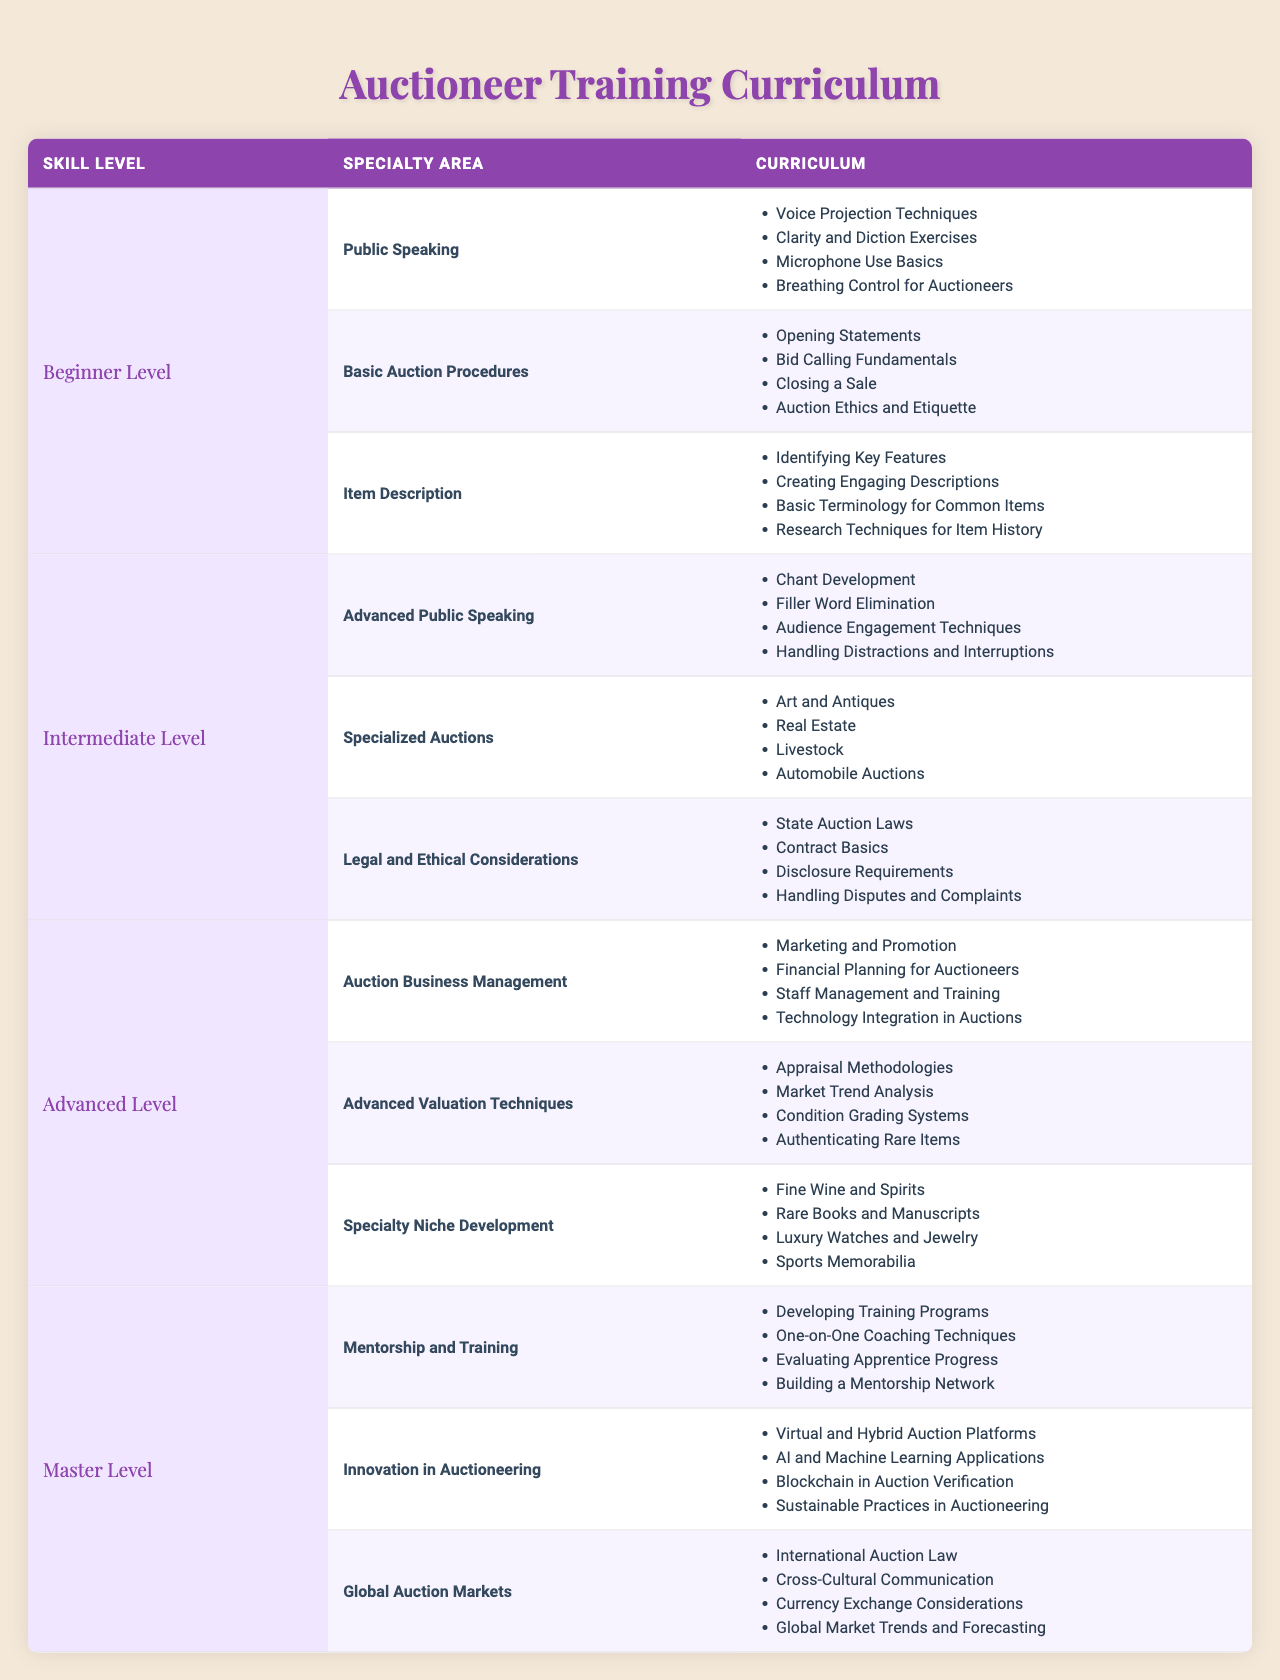What are the curriculum items included in the Basic Auction Procedures at the Beginner Level? The table shows that there are four items under Basic Auction Procedures: Opening Statements, Bid Calling Fundamentals, Closing a Sale, and Auction Ethics and Etiquette. These can be found under the section labeled as Basic Auction Procedures in the Beginner Level category.
Answer: Opening Statements, Bid Calling Fundamentals, Closing a Sale, Auction Ethics and Etiquette Which specialty area at the Intermediate Level covers the auctions for rare items or collectibles? The table lists Specialized Auctions under the Intermediate Level. This area specifically mentions Art and Antiques, which often includes rare items and collectibles, along with Livestock and Automobile Auctions.
Answer: Specialized Auctions How many curriculum items are listed for the Advanced Valuation Techniques specialty area? There are four items listed for Advanced Valuation Techniques: Appraisal Methodologies, Market Trend Analysis, Condition Grading Systems, and Authenticating Rare Items. By counting the items directly from the table, we find that the total is four.
Answer: 4 Does the Advanced Level include any training related to Auction Business Management? Yes, the table confirms that Auction Business Management is included in the Advanced Level curriculum. It is one of the three specialty areas listed under this level.
Answer: Yes Which level has curriculum related to 'Virtual and Hybrid Auction Platforms'? This item is listed under the Innovation in Auctioneering specialty area at the Master Level. Upon examining the table, it is associated with advanced and innovative concepts in auctioneering.
Answer: Master Level What is the relationship between the number of specialty areas and curriculum items in the Beginner Level? The Beginner Level has three specialty areas: Public Speaking, Basic Auction Procedures, and Item Description. Each area contains four curriculum items. Therefore, the total number of curriculum items in this level is 3 (specialty areas) * 4 (items each) = 12 items in total.
Answer: 12 items How does the number of curriculum items in the Master Level compare to that in the Intermediate Level? The Master Level has three specialty areas, each with four curriculum items, totaling 12 items. The Intermediate Level also has three specialty areas, but they contain a different number of items: Advanced Public Speaking has four, Specialized Auctions has four, and Legal and Ethical Considerations has four, which also totals 12 items. Thus, both levels have the same total of curriculum items.
Answer: They are equal; both have 12 items According to the table, which curriculum area focuses on Auction Ethics and Etiquette and at which skill level is it found? Auction Ethics and Etiquette is found under Basic Auction Procedures at the Beginner Level. This can be directly verified by consulting the respective specialty area and level in the table.
Answer: Beginner Level What specialty areas exist at the Advanced Level that focus on Auction Business Management? Auction Business Management is one of the three specialty areas at the Advanced Level, along with Advanced Valuation Techniques and Specialty Niche Development. It indicates a focus on the operational aspects of auctioneering.
Answer: Auction Business Management How would you categorize 'Blockchain in Auction Verification' in terms of skill level and specialty area? 'Blockchain in Auction Verification' is categorized under the Innovation in Auctioneering specialty area at the Master Level, showcasing advanced technological applications in auction practices.
Answer: Master Level, Innovation in Auctioneering 